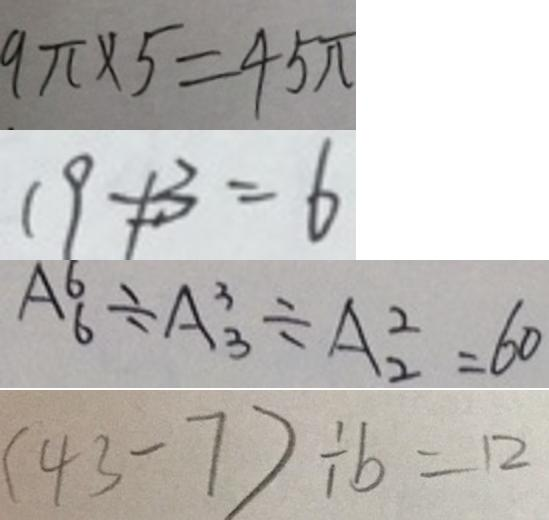<formula> <loc_0><loc_0><loc_500><loc_500>9 \pi \times 5 = 4 5 \pi 
 1 9 \neq 3 = 6 
 A ^ { 6 } _ { 6 } \div A ^ { 3 } _ { 3 } \div A ^ { 2 } _ { 2 } = 6 0 
 ( 4 3 - 7 ) \div b = 1 2</formula> 